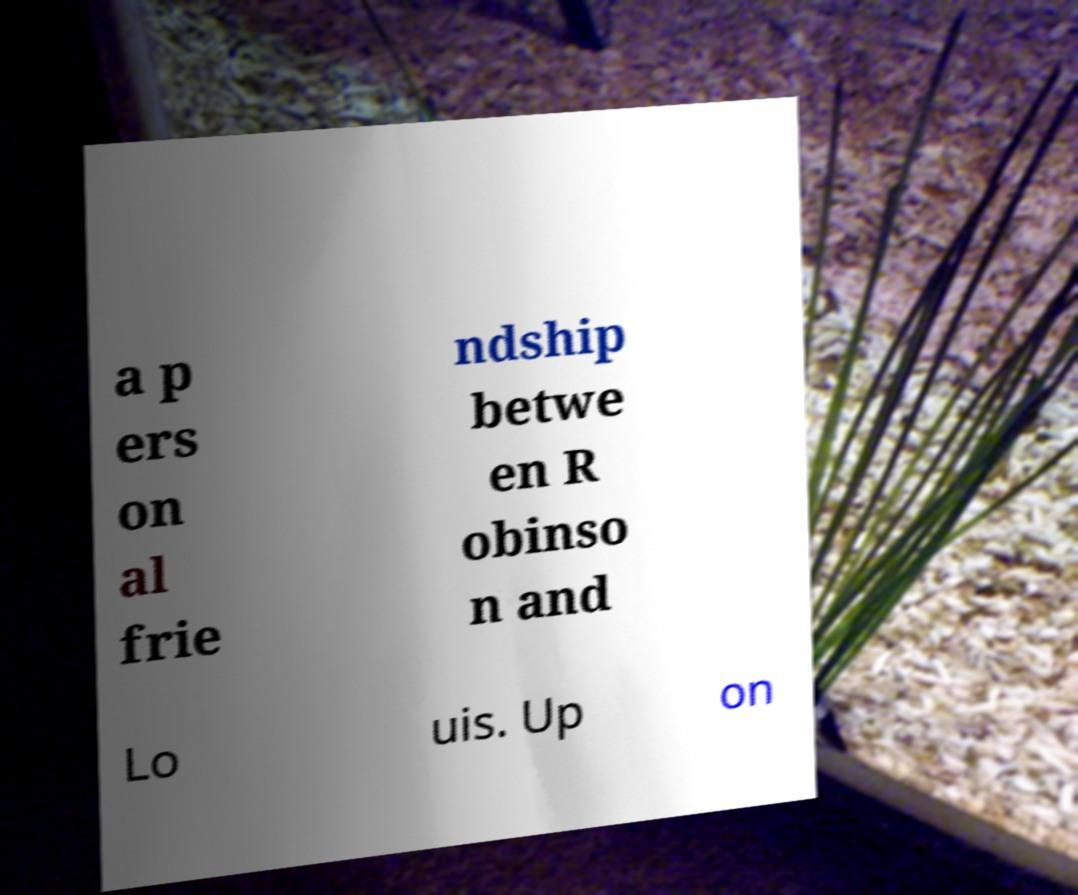What messages or text are displayed in this image? I need them in a readable, typed format. a p ers on al frie ndship betwe en R obinso n and Lo uis. Up on 